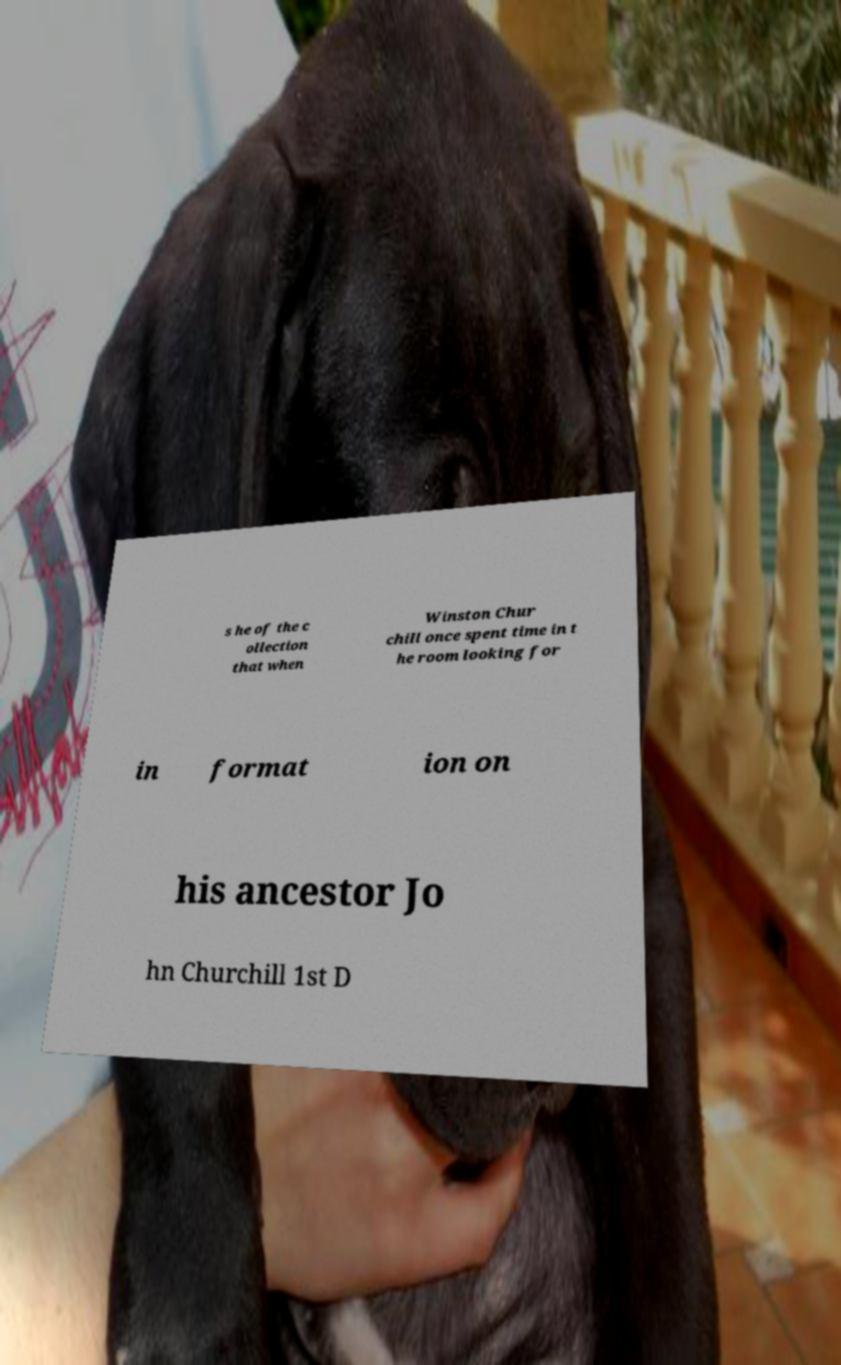Please read and relay the text visible in this image. What does it say? s he of the c ollection that when Winston Chur chill once spent time in t he room looking for in format ion on his ancestor Jo hn Churchill 1st D 